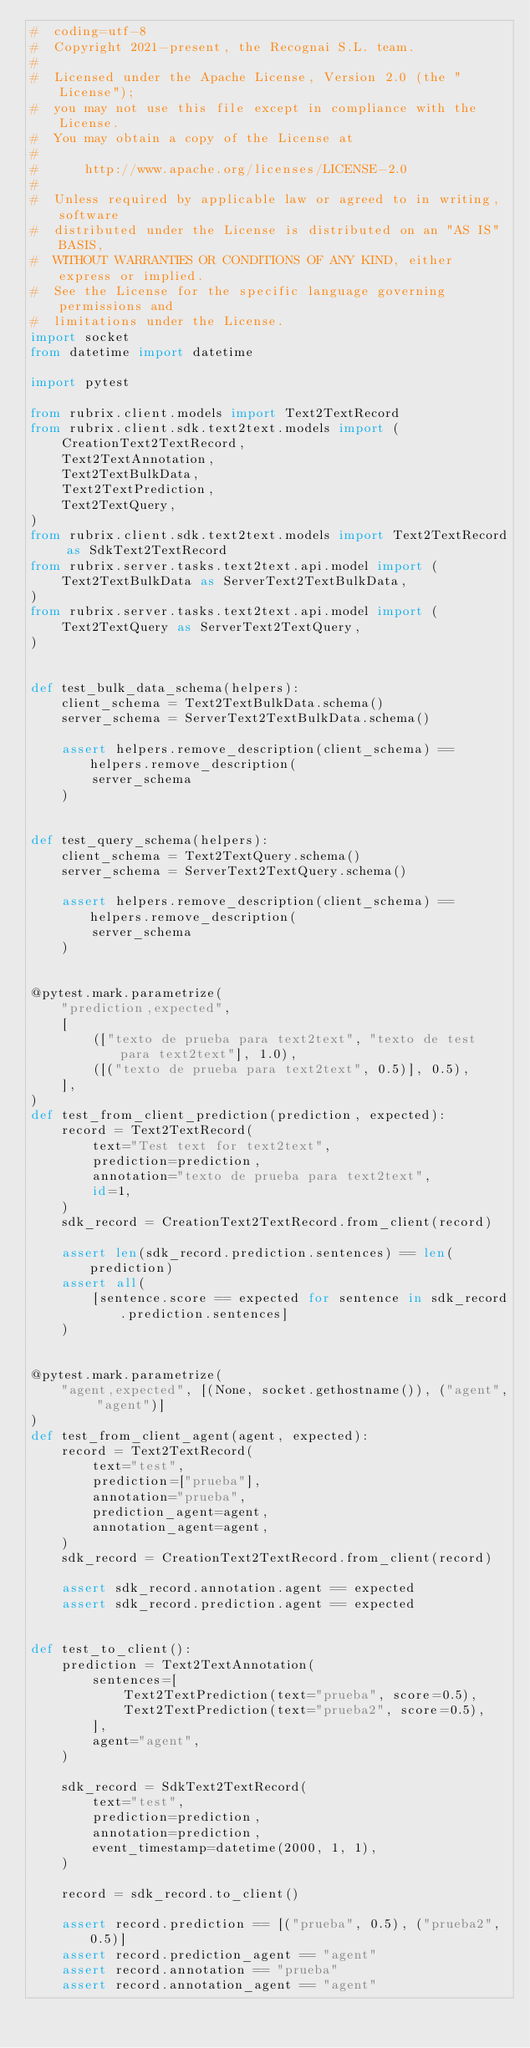<code> <loc_0><loc_0><loc_500><loc_500><_Python_>#  coding=utf-8
#  Copyright 2021-present, the Recognai S.L. team.
#
#  Licensed under the Apache License, Version 2.0 (the "License");
#  you may not use this file except in compliance with the License.
#  You may obtain a copy of the License at
#
#      http://www.apache.org/licenses/LICENSE-2.0
#
#  Unless required by applicable law or agreed to in writing, software
#  distributed under the License is distributed on an "AS IS" BASIS,
#  WITHOUT WARRANTIES OR CONDITIONS OF ANY KIND, either express or implied.
#  See the License for the specific language governing permissions and
#  limitations under the License.
import socket
from datetime import datetime

import pytest

from rubrix.client.models import Text2TextRecord
from rubrix.client.sdk.text2text.models import (
    CreationText2TextRecord,
    Text2TextAnnotation,
    Text2TextBulkData,
    Text2TextPrediction,
    Text2TextQuery,
)
from rubrix.client.sdk.text2text.models import Text2TextRecord as SdkText2TextRecord
from rubrix.server.tasks.text2text.api.model import (
    Text2TextBulkData as ServerText2TextBulkData,
)
from rubrix.server.tasks.text2text.api.model import (
    Text2TextQuery as ServerText2TextQuery,
)


def test_bulk_data_schema(helpers):
    client_schema = Text2TextBulkData.schema()
    server_schema = ServerText2TextBulkData.schema()

    assert helpers.remove_description(client_schema) == helpers.remove_description(
        server_schema
    )


def test_query_schema(helpers):
    client_schema = Text2TextQuery.schema()
    server_schema = ServerText2TextQuery.schema()

    assert helpers.remove_description(client_schema) == helpers.remove_description(
        server_schema
    )


@pytest.mark.parametrize(
    "prediction,expected",
    [
        (["texto de prueba para text2text", "texto de test para text2text"], 1.0),
        ([("texto de prueba para text2text", 0.5)], 0.5),
    ],
)
def test_from_client_prediction(prediction, expected):
    record = Text2TextRecord(
        text="Test text for text2text",
        prediction=prediction,
        annotation="texto de prueba para text2text",
        id=1,
    )
    sdk_record = CreationText2TextRecord.from_client(record)

    assert len(sdk_record.prediction.sentences) == len(prediction)
    assert all(
        [sentence.score == expected for sentence in sdk_record.prediction.sentences]
    )


@pytest.mark.parametrize(
    "agent,expected", [(None, socket.gethostname()), ("agent", "agent")]
)
def test_from_client_agent(agent, expected):
    record = Text2TextRecord(
        text="test",
        prediction=["prueba"],
        annotation="prueba",
        prediction_agent=agent,
        annotation_agent=agent,
    )
    sdk_record = CreationText2TextRecord.from_client(record)

    assert sdk_record.annotation.agent == expected
    assert sdk_record.prediction.agent == expected


def test_to_client():
    prediction = Text2TextAnnotation(
        sentences=[
            Text2TextPrediction(text="prueba", score=0.5),
            Text2TextPrediction(text="prueba2", score=0.5),
        ],
        agent="agent",
    )

    sdk_record = SdkText2TextRecord(
        text="test",
        prediction=prediction,
        annotation=prediction,
        event_timestamp=datetime(2000, 1, 1),
    )

    record = sdk_record.to_client()

    assert record.prediction == [("prueba", 0.5), ("prueba2", 0.5)]
    assert record.prediction_agent == "agent"
    assert record.annotation == "prueba"
    assert record.annotation_agent == "agent"
</code> 